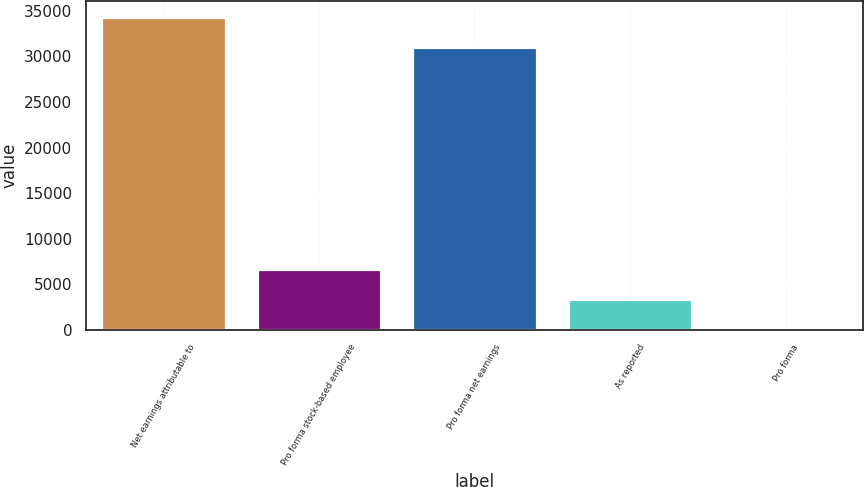<chart> <loc_0><loc_0><loc_500><loc_500><bar_chart><fcel>Net earnings attributable to<fcel>Pro forma stock-based employee<fcel>Pro forma net earnings<fcel>As reported<fcel>Pro forma<nl><fcel>34335.8<fcel>6655.4<fcel>31009<fcel>3328.57<fcel>1.74<nl></chart> 